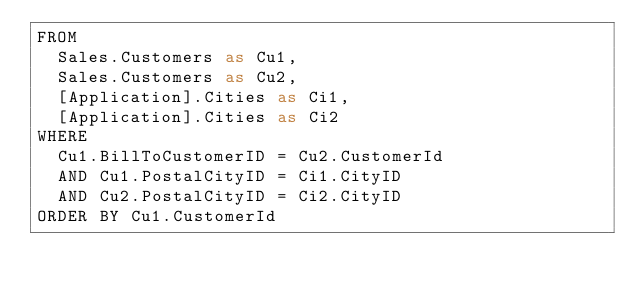Convert code to text. <code><loc_0><loc_0><loc_500><loc_500><_SQL_>FROM
	Sales.Customers as Cu1,
	Sales.Customers as Cu2,
	[Application].Cities as Ci1,
	[Application].Cities as Ci2
WHERE
	Cu1.BillToCustomerID = Cu2.CustomerId
	AND Cu1.PostalCityID = Ci1.CityID
	AND Cu2.PostalCityID = Ci2.CityID
ORDER BY Cu1.CustomerId</code> 